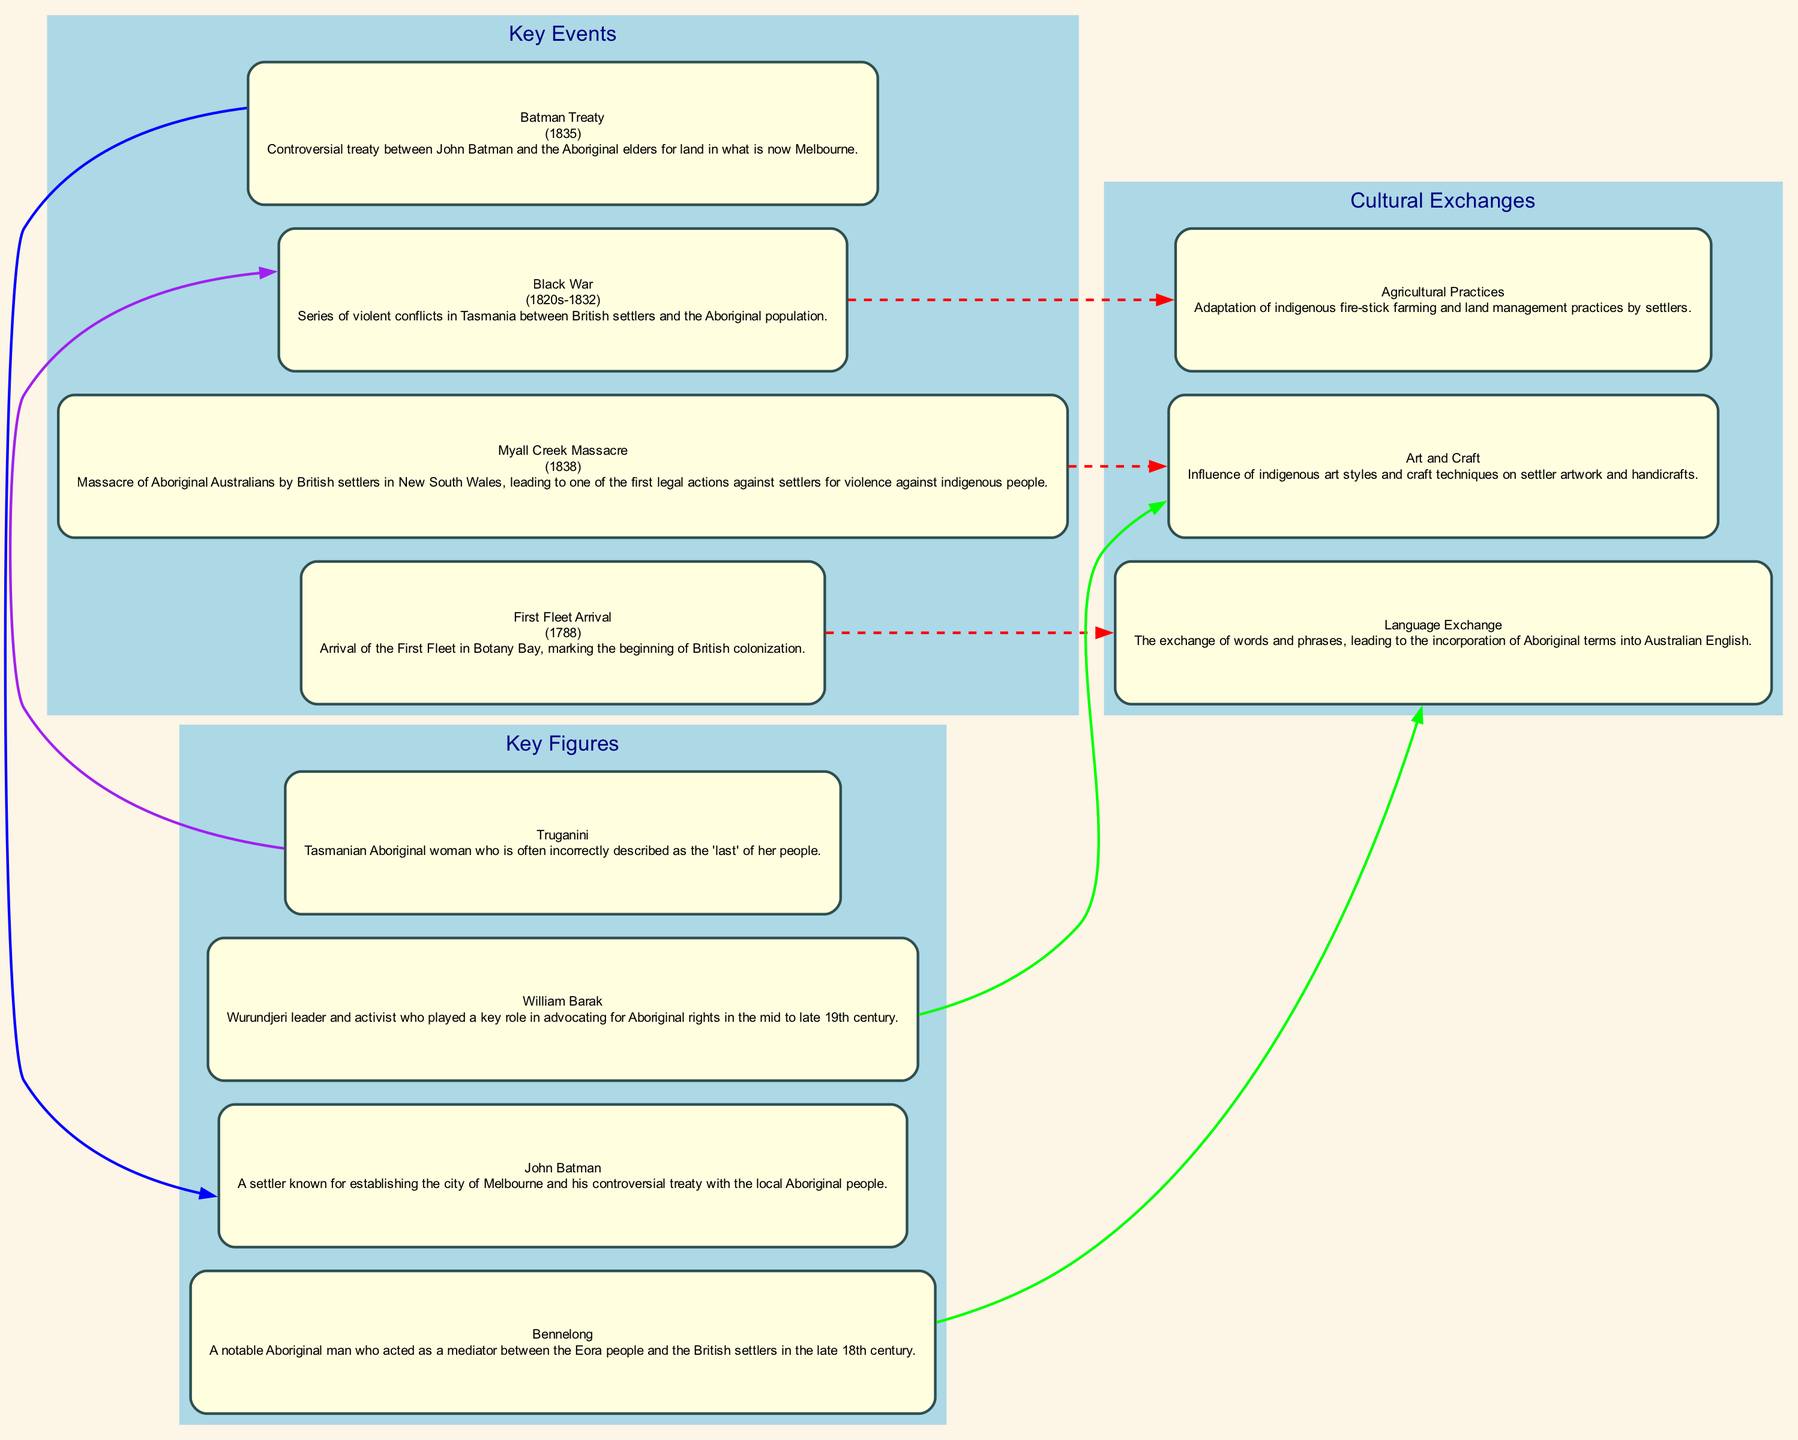What is the year of the First Fleet Arrival? The First Fleet Arrival is marked with the year 1788, which is indicated in the diagram next to the title.
Answer: 1788 How many key events are shown in the diagram? There are four key events listed in the diagram: First Fleet Arrival, Black War, Myall Creek Massacre, and Batman Treaty. This is counted from the key events section.
Answer: 4 What connection is indicated between the Myall Creek Massacre and Art and Craft? The diagram indicates a dashed red edge between 'Myall Creek Massacre' and 'Art and Craft', suggesting a connection of influence or relationship.
Answer: Dashed red edge Who is associated with the Batman Treaty? The Batman Treaty is associated with John Batman, as shown in the connection from the treaty to the figure's node in the diagram.
Answer: John Batman Which cultural exchange relates to Bennelong? The cultural exchange related to Bennelong is 'Language Exchange', as shown by the bold green edge connecting Bennelong's node to the language exchange node.
Answer: Language Exchange What event was associated with the Black War? The Black War is connected to 'Agricultural Practices' through a dashed red edge, indicating a relationship between the two elements in the diagram.
Answer: Agricultural Practices Which key figure played a significant role in advocating for Aboriginal rights? William Barak is the key figure noted for advocating for Aboriginal rights, as described in his node within the diagram.
Answer: William Barak What color is used for connections to cultural exchanges in the diagram? The connections to cultural exchanges are represented by bold green edges, indicating a type of relationship provided in the diagram.
Answer: Bold green edges What does the visual representation of connections suggest about the interactions between settlers and Indigenous Australians? The edges and connections throughout the diagram suggest that various events, figures, and cultural exchanges influence each other, highlighting complex interactions.
Answer: Complex interactions 